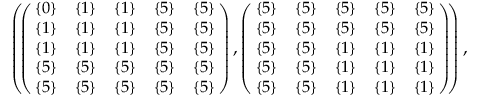Convert formula to latex. <formula><loc_0><loc_0><loc_500><loc_500>\begin{array} { r } { \left ( \, \left ( \, \begin{array} { c c c c c } { \{ 0 \} } & { \{ 1 \} } & { \{ 1 \} } & { \{ 5 \} } & { \{ 5 \} } \\ { \{ 1 \} } & { \{ 1 \} } & { \{ 1 \} } & { \{ 5 \} } & { \{ 5 \} } \\ { \{ 1 \} } & { \{ 1 \} } & { \{ 1 \} } & { \{ 5 \} } & { \{ 5 \} } \\ { \{ 5 \} } & { \{ 5 \} } & { \{ 5 \} } & { \{ 5 \} } & { \{ 5 \} } \\ { \{ 5 \} } & { \{ 5 \} } & { \{ 5 \} } & { \{ 5 \} } & { \{ 5 \} } \end{array} \, \right ) , \left ( \, \begin{array} { c c c c c } { \{ 5 \} } & { \{ 5 \} } & { \{ 5 \} } & { \{ 5 \} } & { \{ 5 \} } \\ { \{ 5 \} } & { \{ 5 \} } & { \{ 5 \} } & { \{ 5 \} } & { \{ 5 \} } \\ { \{ 5 \} } & { \{ 5 \} } & { \{ 1 \} } & { \{ 1 \} } & { \{ 1 \} } \\ { \{ 5 \} } & { \{ 5 \} } & { \{ 1 \} } & { \{ 1 \} } & { \{ 1 \} } \\ { \{ 5 \} } & { \{ 5 \} } & { \{ 1 \} } & { \{ 1 \} } & { \{ 1 \} } \end{array} \, \right ) \, \right ) , } \end{array}</formula> 